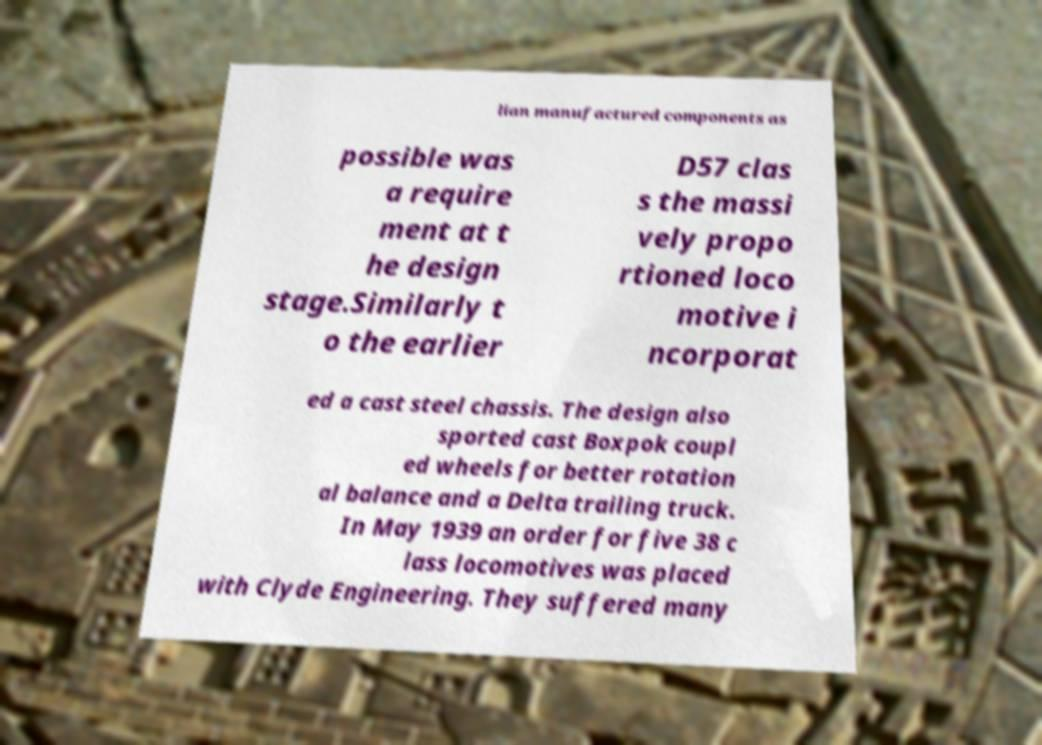I need the written content from this picture converted into text. Can you do that? lian manufactured components as possible was a require ment at t he design stage.Similarly t o the earlier D57 clas s the massi vely propo rtioned loco motive i ncorporat ed a cast steel chassis. The design also sported cast Boxpok coupl ed wheels for better rotation al balance and a Delta trailing truck. In May 1939 an order for five 38 c lass locomotives was placed with Clyde Engineering. They suffered many 